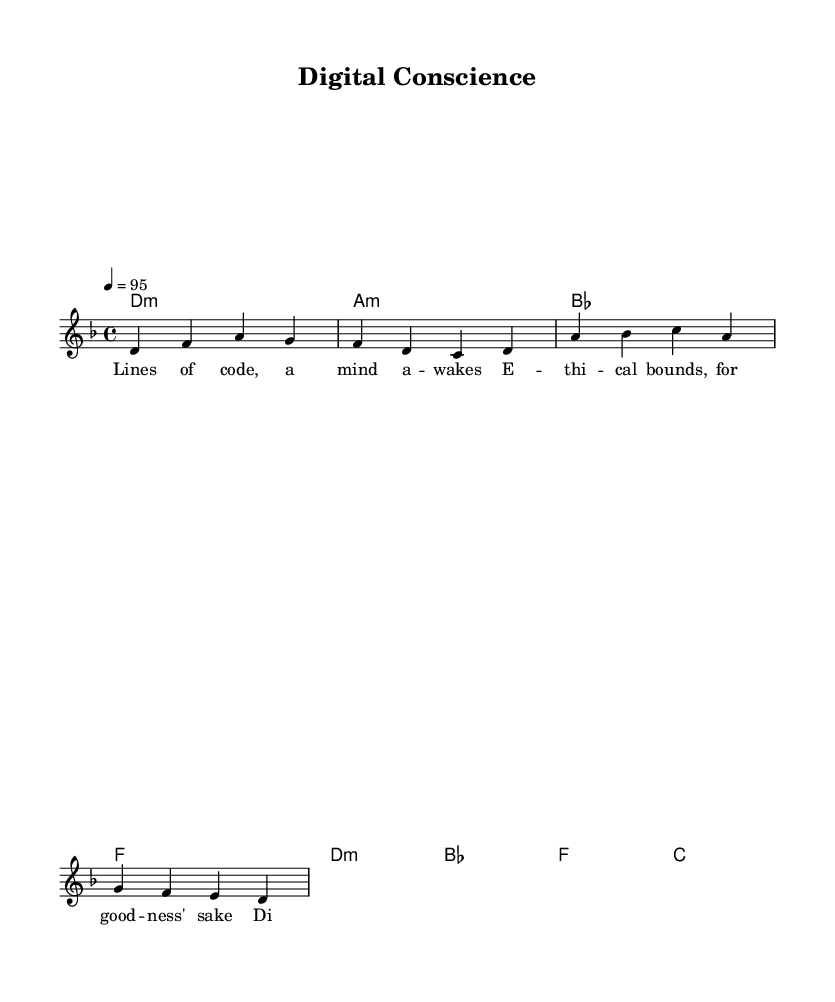What is the key signature of this music? The key signature is D minor, which contains one flat (B flat).
Answer: D minor What is the time signature of this music? The time signature is 4/4, indicating four beats per measure.
Answer: 4/4 What is the tempo marking of this piece? The tempo marking indicates a speed of quarter note = 95 beats per minute.
Answer: 95 How many measures are in the verse section? The verse section has four measures as indicated by the repeated melody and lyrics sections.
Answer: 4 What chord is played in the first measure of the verse? The first measure of the verse shows a D minor chord being played.
Answer: D minor Which word is repeated in the chorus? The word "digital" is repeated in the chorus lyrics.
Answer: digital What is the last note of the chorus melody? The last note of the chorus melody is a D.
Answer: D 